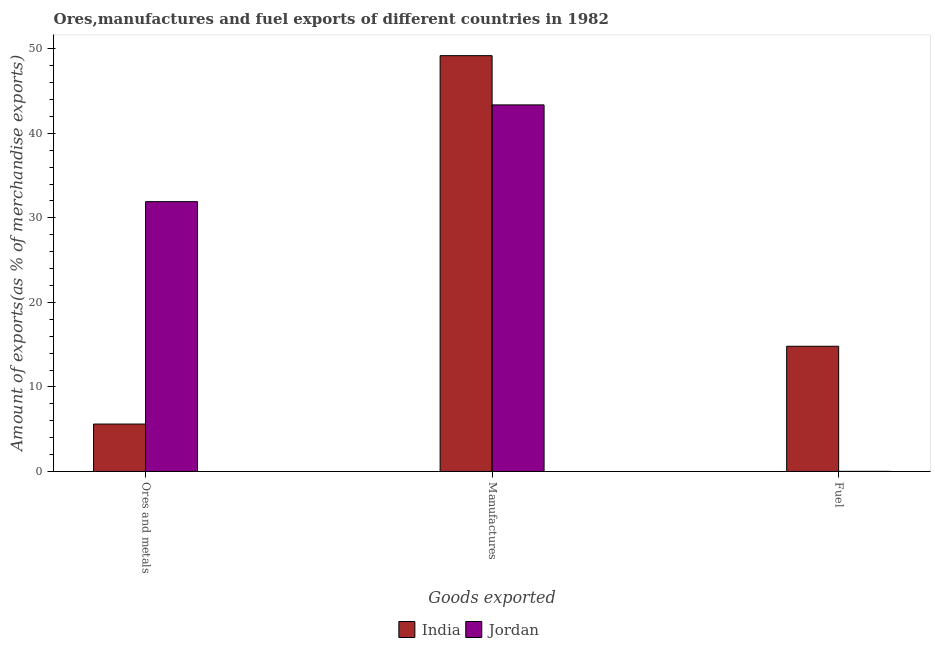How many groups of bars are there?
Offer a terse response. 3. Are the number of bars on each tick of the X-axis equal?
Make the answer very short. Yes. How many bars are there on the 1st tick from the right?
Your answer should be very brief. 2. What is the label of the 2nd group of bars from the left?
Keep it short and to the point. Manufactures. What is the percentage of manufactures exports in India?
Make the answer very short. 49.19. Across all countries, what is the maximum percentage of manufactures exports?
Your answer should be compact. 49.19. Across all countries, what is the minimum percentage of manufactures exports?
Offer a very short reply. 43.37. In which country was the percentage of fuel exports minimum?
Your response must be concise. Jordan. What is the total percentage of ores and metals exports in the graph?
Your answer should be compact. 37.53. What is the difference between the percentage of manufactures exports in India and that in Jordan?
Your answer should be very brief. 5.82. What is the difference between the percentage of manufactures exports in India and the percentage of ores and metals exports in Jordan?
Keep it short and to the point. 17.27. What is the average percentage of fuel exports per country?
Provide a short and direct response. 7.41. What is the difference between the percentage of manufactures exports and percentage of fuel exports in Jordan?
Offer a very short reply. 43.35. What is the ratio of the percentage of manufactures exports in India to that in Jordan?
Your answer should be very brief. 1.13. Is the percentage of ores and metals exports in India less than that in Jordan?
Your answer should be compact. Yes. What is the difference between the highest and the second highest percentage of fuel exports?
Offer a very short reply. 14.8. What is the difference between the highest and the lowest percentage of manufactures exports?
Offer a very short reply. 5.82. In how many countries, is the percentage of fuel exports greater than the average percentage of fuel exports taken over all countries?
Keep it short and to the point. 1. Is the sum of the percentage of manufactures exports in India and Jordan greater than the maximum percentage of fuel exports across all countries?
Offer a very short reply. Yes. What does the 2nd bar from the left in Ores and metals represents?
Provide a short and direct response. Jordan. What does the 1st bar from the right in Fuel represents?
Provide a short and direct response. Jordan. How many bars are there?
Ensure brevity in your answer.  6. Are all the bars in the graph horizontal?
Make the answer very short. No. How many countries are there in the graph?
Your answer should be very brief. 2. Does the graph contain any zero values?
Provide a succinct answer. No. Does the graph contain grids?
Give a very brief answer. No. Where does the legend appear in the graph?
Offer a very short reply. Bottom center. How many legend labels are there?
Keep it short and to the point. 2. What is the title of the graph?
Your response must be concise. Ores,manufactures and fuel exports of different countries in 1982. What is the label or title of the X-axis?
Ensure brevity in your answer.  Goods exported. What is the label or title of the Y-axis?
Provide a succinct answer. Amount of exports(as % of merchandise exports). What is the Amount of exports(as % of merchandise exports) in India in Ores and metals?
Your answer should be very brief. 5.61. What is the Amount of exports(as % of merchandise exports) of Jordan in Ores and metals?
Your response must be concise. 31.92. What is the Amount of exports(as % of merchandise exports) in India in Manufactures?
Your answer should be compact. 49.19. What is the Amount of exports(as % of merchandise exports) in Jordan in Manufactures?
Give a very brief answer. 43.37. What is the Amount of exports(as % of merchandise exports) in India in Fuel?
Your answer should be compact. 14.81. What is the Amount of exports(as % of merchandise exports) of Jordan in Fuel?
Provide a short and direct response. 0.02. Across all Goods exported, what is the maximum Amount of exports(as % of merchandise exports) of India?
Offer a terse response. 49.19. Across all Goods exported, what is the maximum Amount of exports(as % of merchandise exports) in Jordan?
Ensure brevity in your answer.  43.37. Across all Goods exported, what is the minimum Amount of exports(as % of merchandise exports) in India?
Your answer should be compact. 5.61. Across all Goods exported, what is the minimum Amount of exports(as % of merchandise exports) of Jordan?
Offer a very short reply. 0.02. What is the total Amount of exports(as % of merchandise exports) in India in the graph?
Your answer should be compact. 69.62. What is the total Amount of exports(as % of merchandise exports) of Jordan in the graph?
Provide a succinct answer. 75.3. What is the difference between the Amount of exports(as % of merchandise exports) in India in Ores and metals and that in Manufactures?
Your response must be concise. -43.58. What is the difference between the Amount of exports(as % of merchandise exports) of Jordan in Ores and metals and that in Manufactures?
Make the answer very short. -11.45. What is the difference between the Amount of exports(as % of merchandise exports) in India in Ores and metals and that in Fuel?
Ensure brevity in your answer.  -9.2. What is the difference between the Amount of exports(as % of merchandise exports) of Jordan in Ores and metals and that in Fuel?
Ensure brevity in your answer.  31.91. What is the difference between the Amount of exports(as % of merchandise exports) of India in Manufactures and that in Fuel?
Make the answer very short. 34.38. What is the difference between the Amount of exports(as % of merchandise exports) of Jordan in Manufactures and that in Fuel?
Provide a short and direct response. 43.35. What is the difference between the Amount of exports(as % of merchandise exports) in India in Ores and metals and the Amount of exports(as % of merchandise exports) in Jordan in Manufactures?
Make the answer very short. -37.76. What is the difference between the Amount of exports(as % of merchandise exports) in India in Ores and metals and the Amount of exports(as % of merchandise exports) in Jordan in Fuel?
Provide a succinct answer. 5.59. What is the difference between the Amount of exports(as % of merchandise exports) in India in Manufactures and the Amount of exports(as % of merchandise exports) in Jordan in Fuel?
Your answer should be very brief. 49.18. What is the average Amount of exports(as % of merchandise exports) of India per Goods exported?
Offer a terse response. 23.21. What is the average Amount of exports(as % of merchandise exports) in Jordan per Goods exported?
Make the answer very short. 25.1. What is the difference between the Amount of exports(as % of merchandise exports) in India and Amount of exports(as % of merchandise exports) in Jordan in Ores and metals?
Provide a succinct answer. -26.31. What is the difference between the Amount of exports(as % of merchandise exports) of India and Amount of exports(as % of merchandise exports) of Jordan in Manufactures?
Your answer should be very brief. 5.82. What is the difference between the Amount of exports(as % of merchandise exports) of India and Amount of exports(as % of merchandise exports) of Jordan in Fuel?
Ensure brevity in your answer.  14.8. What is the ratio of the Amount of exports(as % of merchandise exports) in India in Ores and metals to that in Manufactures?
Offer a terse response. 0.11. What is the ratio of the Amount of exports(as % of merchandise exports) of Jordan in Ores and metals to that in Manufactures?
Offer a very short reply. 0.74. What is the ratio of the Amount of exports(as % of merchandise exports) of India in Ores and metals to that in Fuel?
Ensure brevity in your answer.  0.38. What is the ratio of the Amount of exports(as % of merchandise exports) in Jordan in Ores and metals to that in Fuel?
Your answer should be compact. 2015.42. What is the ratio of the Amount of exports(as % of merchandise exports) in India in Manufactures to that in Fuel?
Make the answer very short. 3.32. What is the ratio of the Amount of exports(as % of merchandise exports) of Jordan in Manufactures to that in Fuel?
Give a very brief answer. 2738.1. What is the difference between the highest and the second highest Amount of exports(as % of merchandise exports) in India?
Keep it short and to the point. 34.38. What is the difference between the highest and the second highest Amount of exports(as % of merchandise exports) in Jordan?
Ensure brevity in your answer.  11.45. What is the difference between the highest and the lowest Amount of exports(as % of merchandise exports) of India?
Your answer should be compact. 43.58. What is the difference between the highest and the lowest Amount of exports(as % of merchandise exports) in Jordan?
Ensure brevity in your answer.  43.35. 